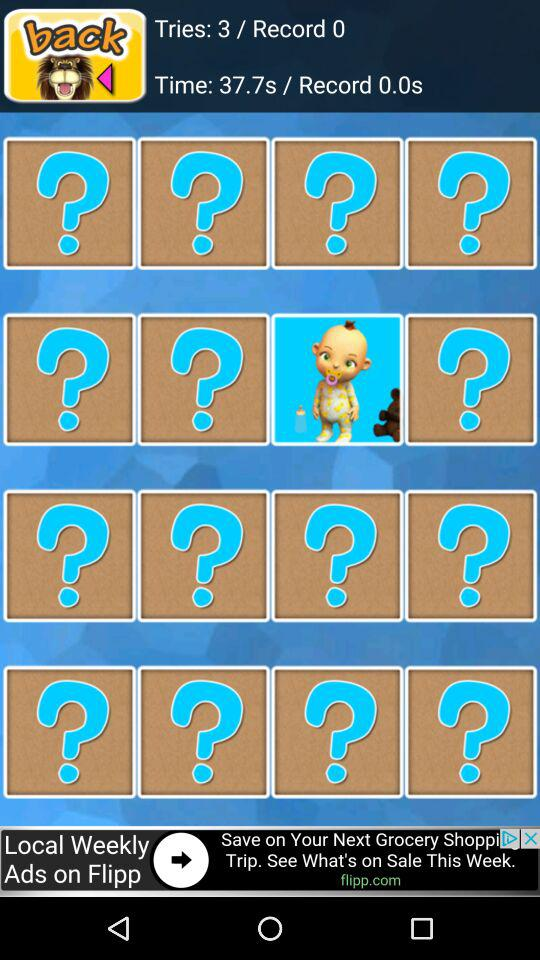How many tries are done? The number of tries is 3. 